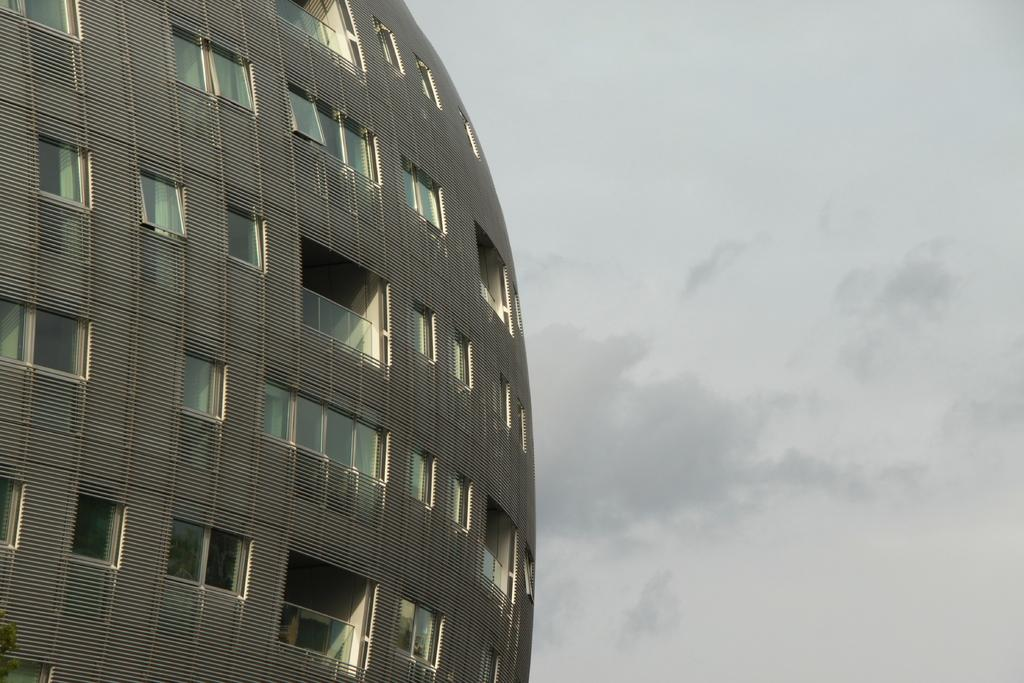What type of structure is visible in the image? There is a building in the image. What is the condition of the sky in the image? The sky is cloudy in the image. How many trees can be seen growing inside the building in the image? There are no trees visible inside the building in the image. What type of shoe is the bear wearing in the image? There is no bear or shoe present in the image. 